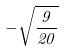Convert formula to latex. <formula><loc_0><loc_0><loc_500><loc_500>- \sqrt { \frac { 9 } { 2 0 } }</formula> 